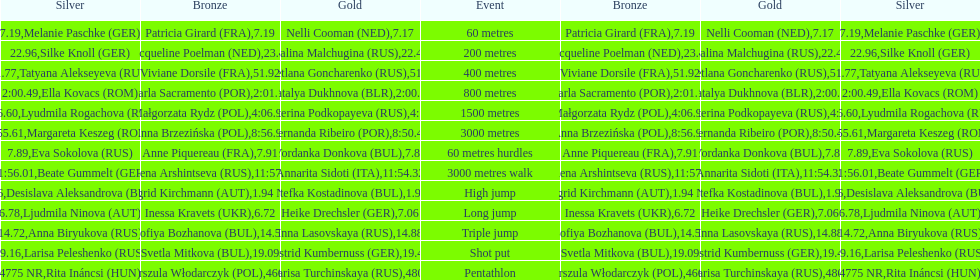How many german women won medals? 5. 